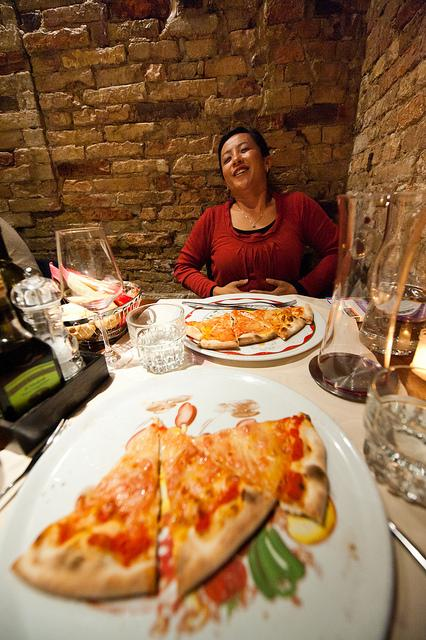What type of food is served here? Please explain your reasoning. italian. Pizza is on a white plate on a table. 